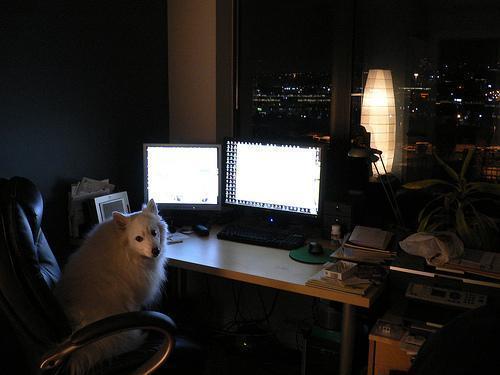How many dogs are there?
Give a very brief answer. 1. How many monitors are there?
Give a very brief answer. 2. 